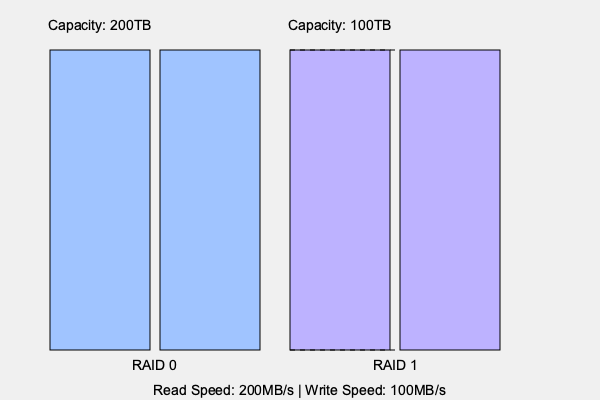Given the visual representation of RAID 0 and RAID 1 configurations, which RAID level would you recommend for a high-traffic application that requires maximum read performance and can tolerate some data loss risk? To answer this question, let's analyze the characteristics of RAID 0 and RAID 1 based on the visual representation:

1. RAID 0 (Striping):
   - Capacity: 200TB (sum of both drives)
   - Read/Write Speed: Implied to be faster than RAID 1
   - Data Protection: No redundancy (higher risk of data loss)

2. RAID 1 (Mirroring):
   - Capacity: 100TB (half of total drive capacity due to mirroring)
   - Read Speed: 200MB/s
   - Write Speed: 100MB/s
   - Data Protection: Full redundancy (lower risk of data loss)

For a high-traffic application requiring maximum read performance:

1. Read Performance: Both RAID 0 and RAID 1 can offer improved read performance compared to a single drive. However, RAID 0 typically provides better read speeds as it can read from multiple drives simultaneously.

2. Capacity: RAID 0 offers full use of all drives (200TB), while RAID 1 only provides half the total capacity (100TB).

3. Data Loss Risk: The question states that some data loss risk can be tolerated. RAID 0 has a higher risk of data loss, but this is acceptable given the requirements.

4. Write Performance: Although not explicitly asked, RAID 0 generally offers better write performance than RAID 1, which is beneficial for high-traffic applications.

Considering these factors, RAID 0 would be the recommended choice for maximizing read performance and capacity, given that some data loss risk is acceptable.
Answer: RAID 0 